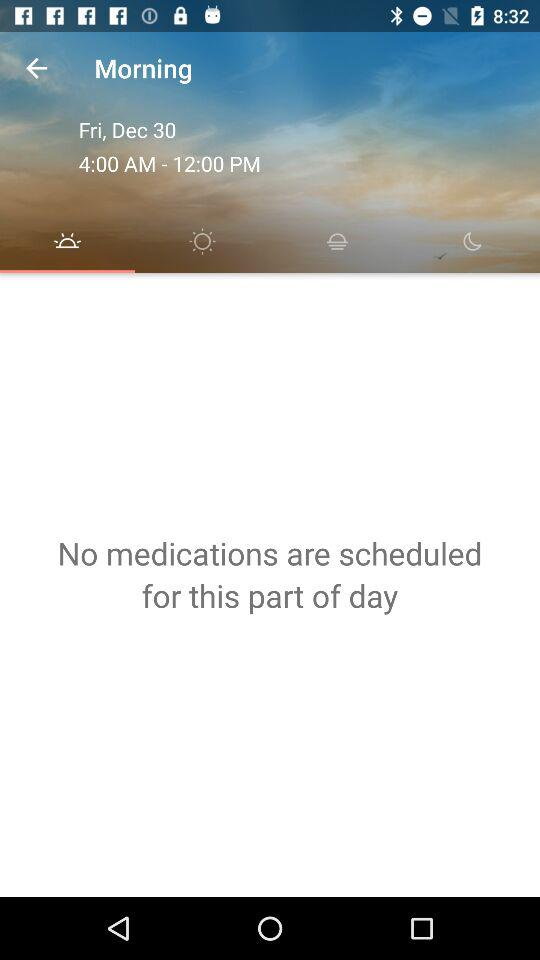Is there any schedule for medication? There is no schedule for medication. 